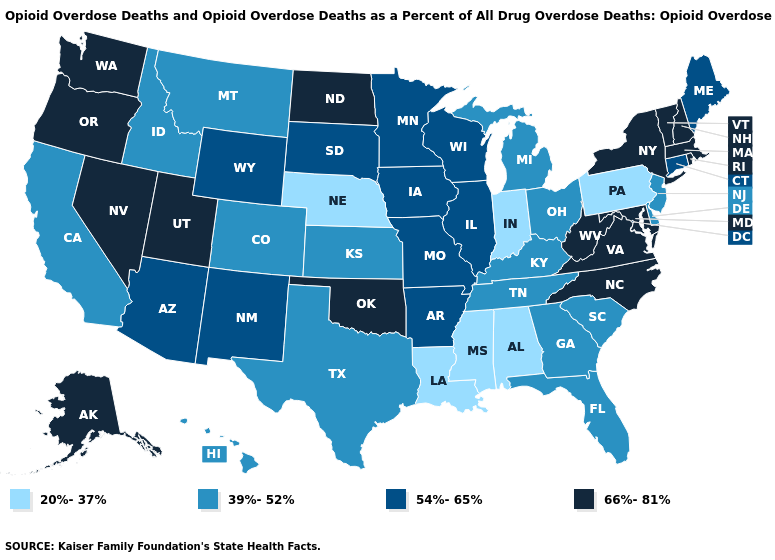Name the states that have a value in the range 39%-52%?
Be succinct. California, Colorado, Delaware, Florida, Georgia, Hawaii, Idaho, Kansas, Kentucky, Michigan, Montana, New Jersey, Ohio, South Carolina, Tennessee, Texas. Which states hav the highest value in the West?
Concise answer only. Alaska, Nevada, Oregon, Utah, Washington. Name the states that have a value in the range 39%-52%?
Concise answer only. California, Colorado, Delaware, Florida, Georgia, Hawaii, Idaho, Kansas, Kentucky, Michigan, Montana, New Jersey, Ohio, South Carolina, Tennessee, Texas. Name the states that have a value in the range 54%-65%?
Be succinct. Arizona, Arkansas, Connecticut, Illinois, Iowa, Maine, Minnesota, Missouri, New Mexico, South Dakota, Wisconsin, Wyoming. What is the value of New York?
Keep it brief. 66%-81%. Which states have the lowest value in the USA?
Answer briefly. Alabama, Indiana, Louisiana, Mississippi, Nebraska, Pennsylvania. Among the states that border Massachusetts , which have the lowest value?
Give a very brief answer. Connecticut. What is the value of Maryland?
Short answer required. 66%-81%. What is the highest value in states that border Oregon?
Quick response, please. 66%-81%. Among the states that border Oregon , which have the lowest value?
Short answer required. California, Idaho. Name the states that have a value in the range 54%-65%?
Be succinct. Arizona, Arkansas, Connecticut, Illinois, Iowa, Maine, Minnesota, Missouri, New Mexico, South Dakota, Wisconsin, Wyoming. What is the highest value in the Northeast ?
Quick response, please. 66%-81%. Which states hav the highest value in the Northeast?
Concise answer only. Massachusetts, New Hampshire, New York, Rhode Island, Vermont. Name the states that have a value in the range 54%-65%?
Keep it brief. Arizona, Arkansas, Connecticut, Illinois, Iowa, Maine, Minnesota, Missouri, New Mexico, South Dakota, Wisconsin, Wyoming. Does the map have missing data?
Short answer required. No. 